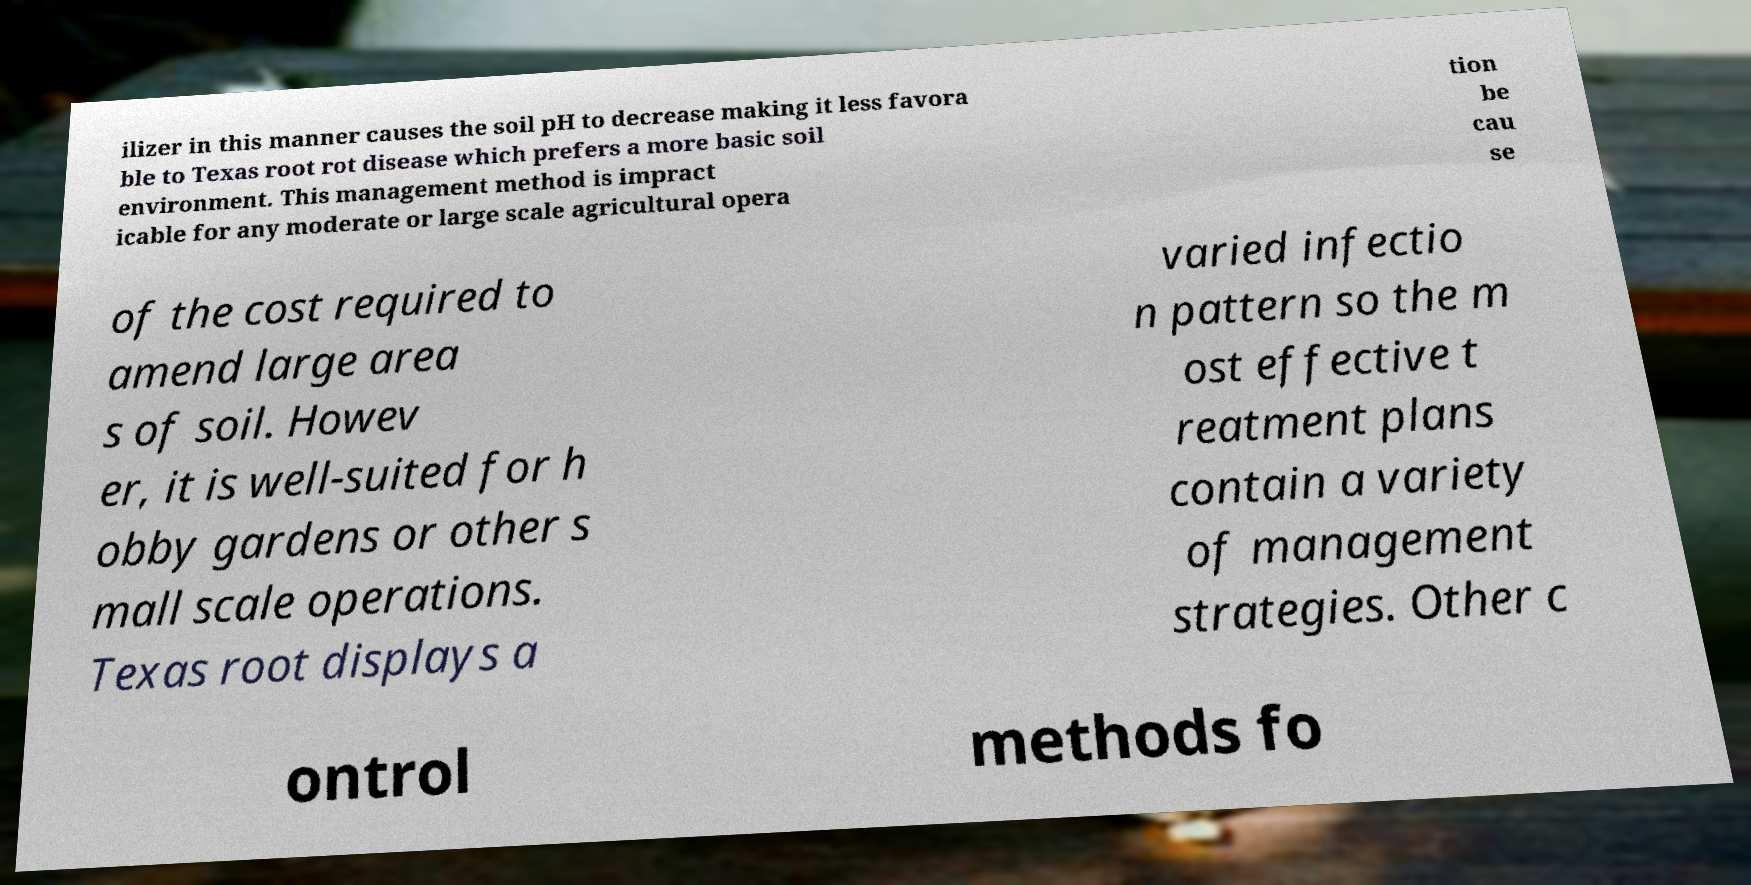There's text embedded in this image that I need extracted. Can you transcribe it verbatim? ilizer in this manner causes the soil pH to decrease making it less favora ble to Texas root rot disease which prefers a more basic soil environment. This management method is impract icable for any moderate or large scale agricultural opera tion be cau se of the cost required to amend large area s of soil. Howev er, it is well-suited for h obby gardens or other s mall scale operations. Texas root displays a varied infectio n pattern so the m ost effective t reatment plans contain a variety of management strategies. Other c ontrol methods fo 